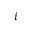<formula> <loc_0><loc_0><loc_500><loc_500>i</formula> 